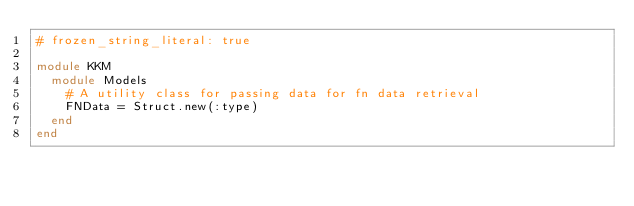Convert code to text. <code><loc_0><loc_0><loc_500><loc_500><_Ruby_># frozen_string_literal: true

module KKM
  module Models
    # A utility class for passing data for fn data retrieval
    FNData = Struct.new(:type)
  end
end
</code> 